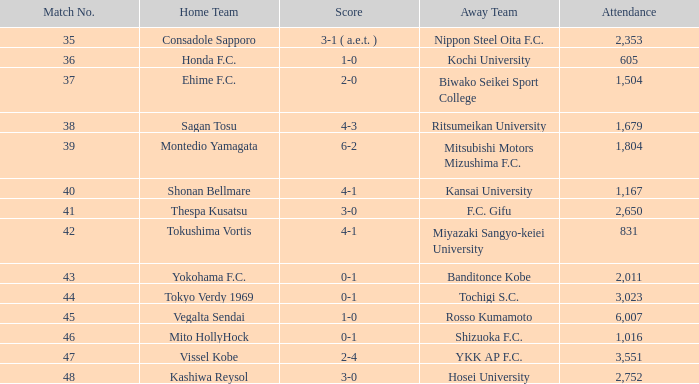After Match 43, what was the Attendance of the Match with a Score of 2-4? 3551.0. 